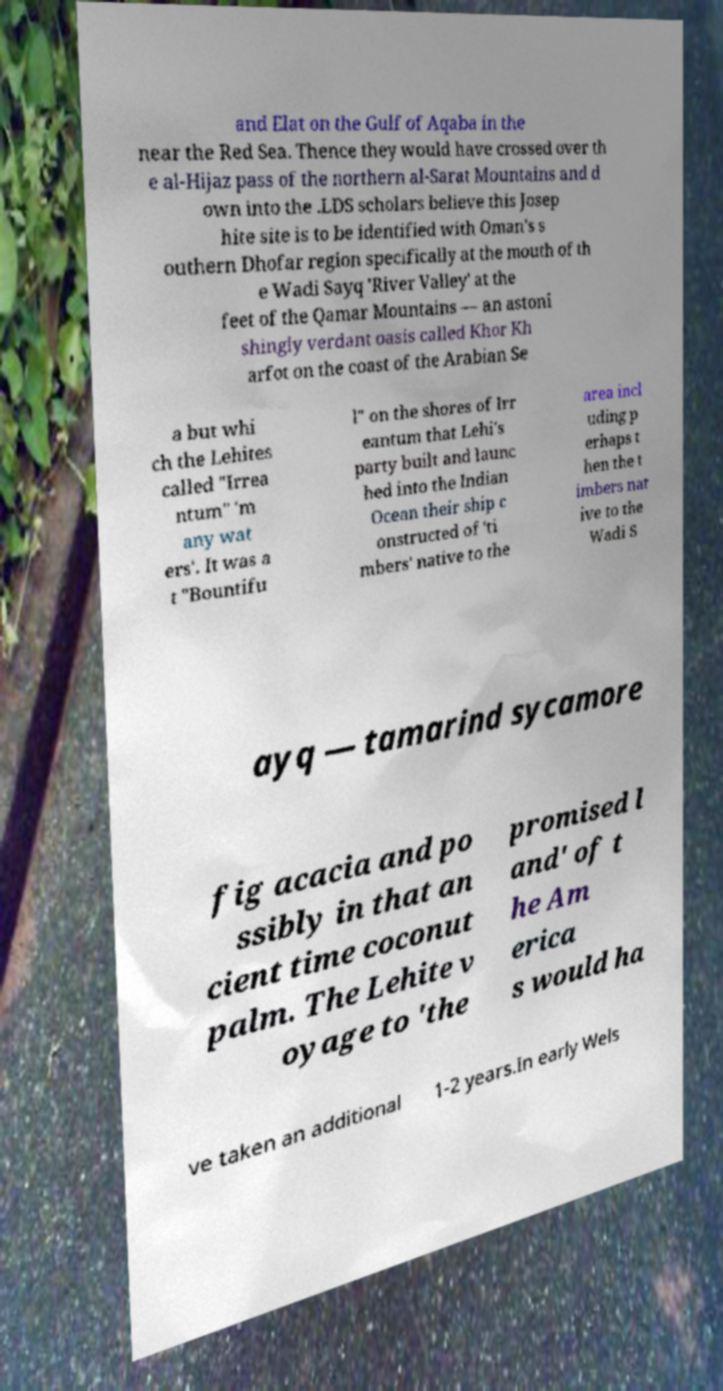Could you assist in decoding the text presented in this image and type it out clearly? and Elat on the Gulf of Aqaba in the near the Red Sea. Thence they would have crossed over th e al-Hijaz pass of the northern al-Sarat Mountains and d own into the .LDS scholars believe this Josep hite site is to be identified with Oman's s outhern Dhofar region specifically at the mouth of th e Wadi Sayq 'River Valley' at the feet of the Qamar Mountains — an astoni shingly verdant oasis called Khor Kh arfot on the coast of the Arabian Se a but whi ch the Lehites called "Irrea ntum" 'm any wat ers'. It was a t "Bountifu l" on the shores of Irr eantum that Lehi's party built and launc hed into the Indian Ocean their ship c onstructed of 'ti mbers' native to the area incl uding p erhaps t hen the t imbers nat ive to the Wadi S ayq — tamarind sycamore fig acacia and po ssibly in that an cient time coconut palm. The Lehite v oyage to 'the promised l and' of t he Am erica s would ha ve taken an additional 1-2 years.In early Wels 